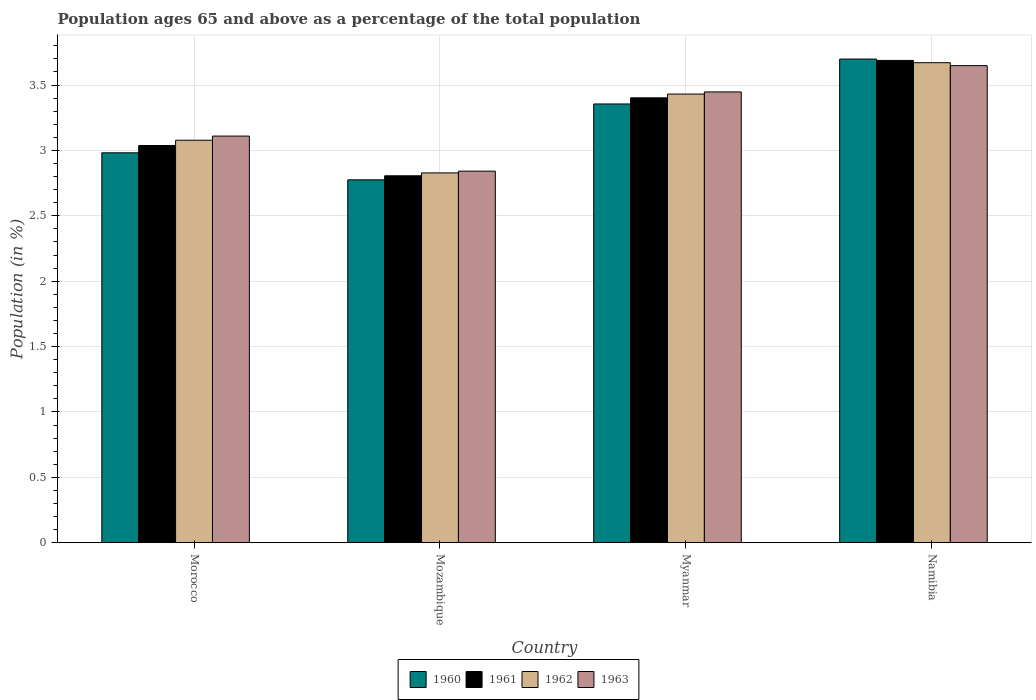How many groups of bars are there?
Ensure brevity in your answer.  4. Are the number of bars on each tick of the X-axis equal?
Make the answer very short. Yes. How many bars are there on the 2nd tick from the right?
Offer a very short reply. 4. What is the label of the 1st group of bars from the left?
Offer a very short reply. Morocco. In how many cases, is the number of bars for a given country not equal to the number of legend labels?
Your answer should be very brief. 0. What is the percentage of the population ages 65 and above in 1960 in Myanmar?
Make the answer very short. 3.36. Across all countries, what is the maximum percentage of the population ages 65 and above in 1960?
Your answer should be compact. 3.7. Across all countries, what is the minimum percentage of the population ages 65 and above in 1963?
Ensure brevity in your answer.  2.84. In which country was the percentage of the population ages 65 and above in 1960 maximum?
Your response must be concise. Namibia. In which country was the percentage of the population ages 65 and above in 1960 minimum?
Give a very brief answer. Mozambique. What is the total percentage of the population ages 65 and above in 1963 in the graph?
Keep it short and to the point. 13.05. What is the difference between the percentage of the population ages 65 and above in 1963 in Mozambique and that in Myanmar?
Provide a short and direct response. -0.61. What is the difference between the percentage of the population ages 65 and above in 1961 in Myanmar and the percentage of the population ages 65 and above in 1960 in Namibia?
Provide a short and direct response. -0.3. What is the average percentage of the population ages 65 and above in 1962 per country?
Provide a short and direct response. 3.25. What is the difference between the percentage of the population ages 65 and above of/in 1963 and percentage of the population ages 65 and above of/in 1961 in Namibia?
Your answer should be compact. -0.04. In how many countries, is the percentage of the population ages 65 and above in 1962 greater than 1.8?
Your answer should be very brief. 4. What is the ratio of the percentage of the population ages 65 and above in 1963 in Morocco to that in Namibia?
Provide a succinct answer. 0.85. Is the percentage of the population ages 65 and above in 1962 in Morocco less than that in Namibia?
Your answer should be very brief. Yes. Is the difference between the percentage of the population ages 65 and above in 1963 in Mozambique and Namibia greater than the difference between the percentage of the population ages 65 and above in 1961 in Mozambique and Namibia?
Make the answer very short. Yes. What is the difference between the highest and the second highest percentage of the population ages 65 and above in 1962?
Provide a succinct answer. -0.24. What is the difference between the highest and the lowest percentage of the population ages 65 and above in 1963?
Give a very brief answer. 0.81. In how many countries, is the percentage of the population ages 65 and above in 1960 greater than the average percentage of the population ages 65 and above in 1960 taken over all countries?
Make the answer very short. 2. What does the 1st bar from the left in Myanmar represents?
Keep it short and to the point. 1960. What does the 4th bar from the right in Mozambique represents?
Provide a succinct answer. 1960. How many countries are there in the graph?
Give a very brief answer. 4. What is the difference between two consecutive major ticks on the Y-axis?
Keep it short and to the point. 0.5. Are the values on the major ticks of Y-axis written in scientific E-notation?
Provide a succinct answer. No. Does the graph contain any zero values?
Provide a succinct answer. No. Does the graph contain grids?
Give a very brief answer. Yes. How many legend labels are there?
Provide a succinct answer. 4. How are the legend labels stacked?
Ensure brevity in your answer.  Horizontal. What is the title of the graph?
Give a very brief answer. Population ages 65 and above as a percentage of the total population. Does "2011" appear as one of the legend labels in the graph?
Provide a succinct answer. No. What is the label or title of the X-axis?
Make the answer very short. Country. What is the Population (in %) of 1960 in Morocco?
Offer a terse response. 2.98. What is the Population (in %) in 1961 in Morocco?
Keep it short and to the point. 3.04. What is the Population (in %) in 1962 in Morocco?
Your response must be concise. 3.08. What is the Population (in %) in 1963 in Morocco?
Provide a short and direct response. 3.11. What is the Population (in %) in 1960 in Mozambique?
Your response must be concise. 2.78. What is the Population (in %) in 1961 in Mozambique?
Provide a succinct answer. 2.81. What is the Population (in %) of 1962 in Mozambique?
Your answer should be compact. 2.83. What is the Population (in %) of 1963 in Mozambique?
Ensure brevity in your answer.  2.84. What is the Population (in %) of 1960 in Myanmar?
Provide a succinct answer. 3.36. What is the Population (in %) of 1961 in Myanmar?
Give a very brief answer. 3.4. What is the Population (in %) of 1962 in Myanmar?
Ensure brevity in your answer.  3.43. What is the Population (in %) in 1963 in Myanmar?
Provide a succinct answer. 3.45. What is the Population (in %) in 1960 in Namibia?
Provide a short and direct response. 3.7. What is the Population (in %) in 1961 in Namibia?
Keep it short and to the point. 3.69. What is the Population (in %) in 1962 in Namibia?
Offer a terse response. 3.67. What is the Population (in %) of 1963 in Namibia?
Offer a very short reply. 3.65. Across all countries, what is the maximum Population (in %) in 1960?
Give a very brief answer. 3.7. Across all countries, what is the maximum Population (in %) of 1961?
Provide a short and direct response. 3.69. Across all countries, what is the maximum Population (in %) of 1962?
Provide a succinct answer. 3.67. Across all countries, what is the maximum Population (in %) in 1963?
Offer a very short reply. 3.65. Across all countries, what is the minimum Population (in %) in 1960?
Provide a short and direct response. 2.78. Across all countries, what is the minimum Population (in %) in 1961?
Your answer should be very brief. 2.81. Across all countries, what is the minimum Population (in %) in 1962?
Offer a very short reply. 2.83. Across all countries, what is the minimum Population (in %) in 1963?
Your response must be concise. 2.84. What is the total Population (in %) of 1960 in the graph?
Provide a succinct answer. 12.81. What is the total Population (in %) in 1961 in the graph?
Offer a very short reply. 12.93. What is the total Population (in %) in 1962 in the graph?
Your answer should be very brief. 13.01. What is the total Population (in %) of 1963 in the graph?
Provide a short and direct response. 13.05. What is the difference between the Population (in %) of 1960 in Morocco and that in Mozambique?
Offer a very short reply. 0.21. What is the difference between the Population (in %) in 1961 in Morocco and that in Mozambique?
Keep it short and to the point. 0.23. What is the difference between the Population (in %) of 1962 in Morocco and that in Mozambique?
Your answer should be very brief. 0.25. What is the difference between the Population (in %) in 1963 in Morocco and that in Mozambique?
Ensure brevity in your answer.  0.27. What is the difference between the Population (in %) of 1960 in Morocco and that in Myanmar?
Your answer should be very brief. -0.37. What is the difference between the Population (in %) of 1961 in Morocco and that in Myanmar?
Ensure brevity in your answer.  -0.36. What is the difference between the Population (in %) of 1962 in Morocco and that in Myanmar?
Your answer should be compact. -0.35. What is the difference between the Population (in %) in 1963 in Morocco and that in Myanmar?
Ensure brevity in your answer.  -0.34. What is the difference between the Population (in %) in 1960 in Morocco and that in Namibia?
Provide a short and direct response. -0.72. What is the difference between the Population (in %) of 1961 in Morocco and that in Namibia?
Provide a succinct answer. -0.65. What is the difference between the Population (in %) of 1962 in Morocco and that in Namibia?
Provide a succinct answer. -0.59. What is the difference between the Population (in %) in 1963 in Morocco and that in Namibia?
Your answer should be compact. -0.54. What is the difference between the Population (in %) in 1960 in Mozambique and that in Myanmar?
Your response must be concise. -0.58. What is the difference between the Population (in %) of 1961 in Mozambique and that in Myanmar?
Provide a short and direct response. -0.6. What is the difference between the Population (in %) in 1962 in Mozambique and that in Myanmar?
Your answer should be very brief. -0.6. What is the difference between the Population (in %) in 1963 in Mozambique and that in Myanmar?
Provide a short and direct response. -0.61. What is the difference between the Population (in %) in 1960 in Mozambique and that in Namibia?
Ensure brevity in your answer.  -0.92. What is the difference between the Population (in %) of 1961 in Mozambique and that in Namibia?
Offer a terse response. -0.88. What is the difference between the Population (in %) of 1962 in Mozambique and that in Namibia?
Give a very brief answer. -0.84. What is the difference between the Population (in %) in 1963 in Mozambique and that in Namibia?
Keep it short and to the point. -0.81. What is the difference between the Population (in %) in 1960 in Myanmar and that in Namibia?
Provide a short and direct response. -0.34. What is the difference between the Population (in %) in 1961 in Myanmar and that in Namibia?
Provide a short and direct response. -0.29. What is the difference between the Population (in %) of 1962 in Myanmar and that in Namibia?
Your response must be concise. -0.24. What is the difference between the Population (in %) in 1963 in Myanmar and that in Namibia?
Your answer should be compact. -0.2. What is the difference between the Population (in %) in 1960 in Morocco and the Population (in %) in 1961 in Mozambique?
Offer a very short reply. 0.18. What is the difference between the Population (in %) of 1960 in Morocco and the Population (in %) of 1962 in Mozambique?
Your response must be concise. 0.15. What is the difference between the Population (in %) in 1960 in Morocco and the Population (in %) in 1963 in Mozambique?
Offer a terse response. 0.14. What is the difference between the Population (in %) in 1961 in Morocco and the Population (in %) in 1962 in Mozambique?
Provide a succinct answer. 0.21. What is the difference between the Population (in %) in 1961 in Morocco and the Population (in %) in 1963 in Mozambique?
Offer a very short reply. 0.2. What is the difference between the Population (in %) in 1962 in Morocco and the Population (in %) in 1963 in Mozambique?
Your response must be concise. 0.24. What is the difference between the Population (in %) of 1960 in Morocco and the Population (in %) of 1961 in Myanmar?
Offer a very short reply. -0.42. What is the difference between the Population (in %) in 1960 in Morocco and the Population (in %) in 1962 in Myanmar?
Provide a short and direct response. -0.45. What is the difference between the Population (in %) of 1960 in Morocco and the Population (in %) of 1963 in Myanmar?
Offer a very short reply. -0.47. What is the difference between the Population (in %) in 1961 in Morocco and the Population (in %) in 1962 in Myanmar?
Your answer should be very brief. -0.39. What is the difference between the Population (in %) in 1961 in Morocco and the Population (in %) in 1963 in Myanmar?
Make the answer very short. -0.41. What is the difference between the Population (in %) of 1962 in Morocco and the Population (in %) of 1963 in Myanmar?
Your answer should be compact. -0.37. What is the difference between the Population (in %) in 1960 in Morocco and the Population (in %) in 1961 in Namibia?
Provide a short and direct response. -0.71. What is the difference between the Population (in %) in 1960 in Morocco and the Population (in %) in 1962 in Namibia?
Give a very brief answer. -0.69. What is the difference between the Population (in %) of 1960 in Morocco and the Population (in %) of 1963 in Namibia?
Offer a very short reply. -0.67. What is the difference between the Population (in %) in 1961 in Morocco and the Population (in %) in 1962 in Namibia?
Your response must be concise. -0.63. What is the difference between the Population (in %) in 1961 in Morocco and the Population (in %) in 1963 in Namibia?
Your response must be concise. -0.61. What is the difference between the Population (in %) of 1962 in Morocco and the Population (in %) of 1963 in Namibia?
Offer a terse response. -0.57. What is the difference between the Population (in %) of 1960 in Mozambique and the Population (in %) of 1961 in Myanmar?
Your answer should be very brief. -0.63. What is the difference between the Population (in %) of 1960 in Mozambique and the Population (in %) of 1962 in Myanmar?
Your response must be concise. -0.66. What is the difference between the Population (in %) of 1960 in Mozambique and the Population (in %) of 1963 in Myanmar?
Your answer should be compact. -0.67. What is the difference between the Population (in %) of 1961 in Mozambique and the Population (in %) of 1962 in Myanmar?
Provide a short and direct response. -0.62. What is the difference between the Population (in %) in 1961 in Mozambique and the Population (in %) in 1963 in Myanmar?
Your answer should be compact. -0.64. What is the difference between the Population (in %) in 1962 in Mozambique and the Population (in %) in 1963 in Myanmar?
Provide a succinct answer. -0.62. What is the difference between the Population (in %) of 1960 in Mozambique and the Population (in %) of 1961 in Namibia?
Offer a very short reply. -0.91. What is the difference between the Population (in %) of 1960 in Mozambique and the Population (in %) of 1962 in Namibia?
Keep it short and to the point. -0.9. What is the difference between the Population (in %) in 1960 in Mozambique and the Population (in %) in 1963 in Namibia?
Keep it short and to the point. -0.87. What is the difference between the Population (in %) of 1961 in Mozambique and the Population (in %) of 1962 in Namibia?
Offer a very short reply. -0.86. What is the difference between the Population (in %) of 1961 in Mozambique and the Population (in %) of 1963 in Namibia?
Provide a succinct answer. -0.84. What is the difference between the Population (in %) in 1962 in Mozambique and the Population (in %) in 1963 in Namibia?
Your response must be concise. -0.82. What is the difference between the Population (in %) in 1960 in Myanmar and the Population (in %) in 1961 in Namibia?
Your answer should be very brief. -0.33. What is the difference between the Population (in %) in 1960 in Myanmar and the Population (in %) in 1962 in Namibia?
Give a very brief answer. -0.32. What is the difference between the Population (in %) in 1960 in Myanmar and the Population (in %) in 1963 in Namibia?
Provide a succinct answer. -0.29. What is the difference between the Population (in %) of 1961 in Myanmar and the Population (in %) of 1962 in Namibia?
Make the answer very short. -0.27. What is the difference between the Population (in %) in 1961 in Myanmar and the Population (in %) in 1963 in Namibia?
Your answer should be very brief. -0.25. What is the difference between the Population (in %) in 1962 in Myanmar and the Population (in %) in 1963 in Namibia?
Your answer should be very brief. -0.22. What is the average Population (in %) in 1960 per country?
Your answer should be compact. 3.2. What is the average Population (in %) of 1961 per country?
Offer a very short reply. 3.23. What is the average Population (in %) of 1962 per country?
Keep it short and to the point. 3.25. What is the average Population (in %) in 1963 per country?
Offer a terse response. 3.26. What is the difference between the Population (in %) in 1960 and Population (in %) in 1961 in Morocco?
Offer a terse response. -0.06. What is the difference between the Population (in %) of 1960 and Population (in %) of 1962 in Morocco?
Your answer should be very brief. -0.1. What is the difference between the Population (in %) of 1960 and Population (in %) of 1963 in Morocco?
Offer a very short reply. -0.13. What is the difference between the Population (in %) in 1961 and Population (in %) in 1962 in Morocco?
Give a very brief answer. -0.04. What is the difference between the Population (in %) of 1961 and Population (in %) of 1963 in Morocco?
Ensure brevity in your answer.  -0.07. What is the difference between the Population (in %) of 1962 and Population (in %) of 1963 in Morocco?
Offer a terse response. -0.03. What is the difference between the Population (in %) in 1960 and Population (in %) in 1961 in Mozambique?
Your answer should be very brief. -0.03. What is the difference between the Population (in %) in 1960 and Population (in %) in 1962 in Mozambique?
Make the answer very short. -0.05. What is the difference between the Population (in %) in 1960 and Population (in %) in 1963 in Mozambique?
Offer a terse response. -0.07. What is the difference between the Population (in %) of 1961 and Population (in %) of 1962 in Mozambique?
Make the answer very short. -0.02. What is the difference between the Population (in %) of 1961 and Population (in %) of 1963 in Mozambique?
Provide a short and direct response. -0.04. What is the difference between the Population (in %) in 1962 and Population (in %) in 1963 in Mozambique?
Give a very brief answer. -0.01. What is the difference between the Population (in %) of 1960 and Population (in %) of 1961 in Myanmar?
Your answer should be very brief. -0.05. What is the difference between the Population (in %) of 1960 and Population (in %) of 1962 in Myanmar?
Offer a very short reply. -0.08. What is the difference between the Population (in %) in 1960 and Population (in %) in 1963 in Myanmar?
Keep it short and to the point. -0.09. What is the difference between the Population (in %) of 1961 and Population (in %) of 1962 in Myanmar?
Give a very brief answer. -0.03. What is the difference between the Population (in %) in 1961 and Population (in %) in 1963 in Myanmar?
Keep it short and to the point. -0.04. What is the difference between the Population (in %) of 1962 and Population (in %) of 1963 in Myanmar?
Your answer should be very brief. -0.02. What is the difference between the Population (in %) in 1960 and Population (in %) in 1961 in Namibia?
Your response must be concise. 0.01. What is the difference between the Population (in %) in 1960 and Population (in %) in 1962 in Namibia?
Give a very brief answer. 0.03. What is the difference between the Population (in %) of 1960 and Population (in %) of 1963 in Namibia?
Provide a succinct answer. 0.05. What is the difference between the Population (in %) in 1961 and Population (in %) in 1962 in Namibia?
Your response must be concise. 0.02. What is the difference between the Population (in %) in 1961 and Population (in %) in 1963 in Namibia?
Provide a succinct answer. 0.04. What is the difference between the Population (in %) of 1962 and Population (in %) of 1963 in Namibia?
Offer a terse response. 0.02. What is the ratio of the Population (in %) in 1960 in Morocco to that in Mozambique?
Provide a succinct answer. 1.07. What is the ratio of the Population (in %) in 1961 in Morocco to that in Mozambique?
Offer a terse response. 1.08. What is the ratio of the Population (in %) in 1962 in Morocco to that in Mozambique?
Your answer should be compact. 1.09. What is the ratio of the Population (in %) of 1963 in Morocco to that in Mozambique?
Give a very brief answer. 1.09. What is the ratio of the Population (in %) in 1960 in Morocco to that in Myanmar?
Offer a very short reply. 0.89. What is the ratio of the Population (in %) in 1961 in Morocco to that in Myanmar?
Your response must be concise. 0.89. What is the ratio of the Population (in %) of 1962 in Morocco to that in Myanmar?
Provide a succinct answer. 0.9. What is the ratio of the Population (in %) in 1963 in Morocco to that in Myanmar?
Your response must be concise. 0.9. What is the ratio of the Population (in %) of 1960 in Morocco to that in Namibia?
Give a very brief answer. 0.81. What is the ratio of the Population (in %) of 1961 in Morocco to that in Namibia?
Make the answer very short. 0.82. What is the ratio of the Population (in %) in 1962 in Morocco to that in Namibia?
Your response must be concise. 0.84. What is the ratio of the Population (in %) of 1963 in Morocco to that in Namibia?
Make the answer very short. 0.85. What is the ratio of the Population (in %) in 1960 in Mozambique to that in Myanmar?
Provide a succinct answer. 0.83. What is the ratio of the Population (in %) of 1961 in Mozambique to that in Myanmar?
Your answer should be compact. 0.82. What is the ratio of the Population (in %) in 1962 in Mozambique to that in Myanmar?
Provide a succinct answer. 0.82. What is the ratio of the Population (in %) in 1963 in Mozambique to that in Myanmar?
Provide a succinct answer. 0.82. What is the ratio of the Population (in %) of 1960 in Mozambique to that in Namibia?
Offer a very short reply. 0.75. What is the ratio of the Population (in %) in 1961 in Mozambique to that in Namibia?
Provide a succinct answer. 0.76. What is the ratio of the Population (in %) in 1962 in Mozambique to that in Namibia?
Make the answer very short. 0.77. What is the ratio of the Population (in %) of 1963 in Mozambique to that in Namibia?
Your response must be concise. 0.78. What is the ratio of the Population (in %) in 1960 in Myanmar to that in Namibia?
Provide a succinct answer. 0.91. What is the ratio of the Population (in %) of 1961 in Myanmar to that in Namibia?
Make the answer very short. 0.92. What is the ratio of the Population (in %) in 1962 in Myanmar to that in Namibia?
Provide a succinct answer. 0.93. What is the ratio of the Population (in %) of 1963 in Myanmar to that in Namibia?
Keep it short and to the point. 0.94. What is the difference between the highest and the second highest Population (in %) of 1960?
Keep it short and to the point. 0.34. What is the difference between the highest and the second highest Population (in %) in 1961?
Offer a very short reply. 0.29. What is the difference between the highest and the second highest Population (in %) in 1962?
Your answer should be compact. 0.24. What is the difference between the highest and the second highest Population (in %) of 1963?
Make the answer very short. 0.2. What is the difference between the highest and the lowest Population (in %) in 1960?
Provide a succinct answer. 0.92. What is the difference between the highest and the lowest Population (in %) of 1961?
Provide a short and direct response. 0.88. What is the difference between the highest and the lowest Population (in %) in 1962?
Give a very brief answer. 0.84. What is the difference between the highest and the lowest Population (in %) in 1963?
Offer a very short reply. 0.81. 